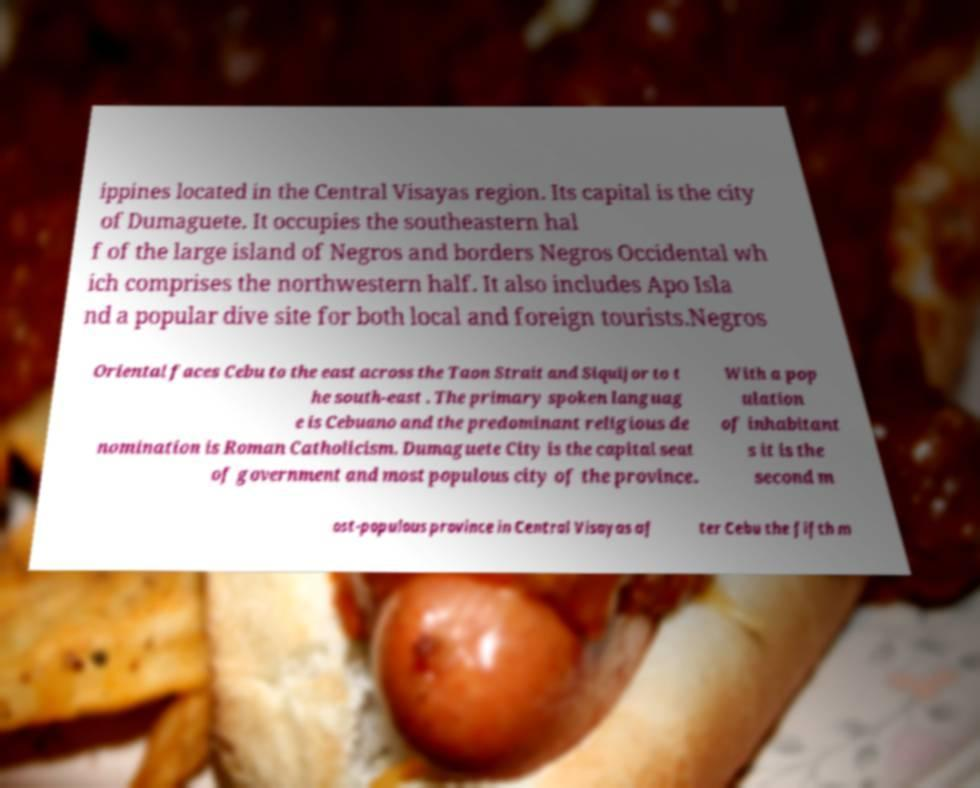For documentation purposes, I need the text within this image transcribed. Could you provide that? ippines located in the Central Visayas region. Its capital is the city of Dumaguete. It occupies the southeastern hal f of the large island of Negros and borders Negros Occidental wh ich comprises the northwestern half. It also includes Apo Isla nd a popular dive site for both local and foreign tourists.Negros Oriental faces Cebu to the east across the Taon Strait and Siquijor to t he south-east . The primary spoken languag e is Cebuano and the predominant religious de nomination is Roman Catholicism. Dumaguete City is the capital seat of government and most populous city of the province. With a pop ulation of inhabitant s it is the second m ost-populous province in Central Visayas af ter Cebu the fifth m 